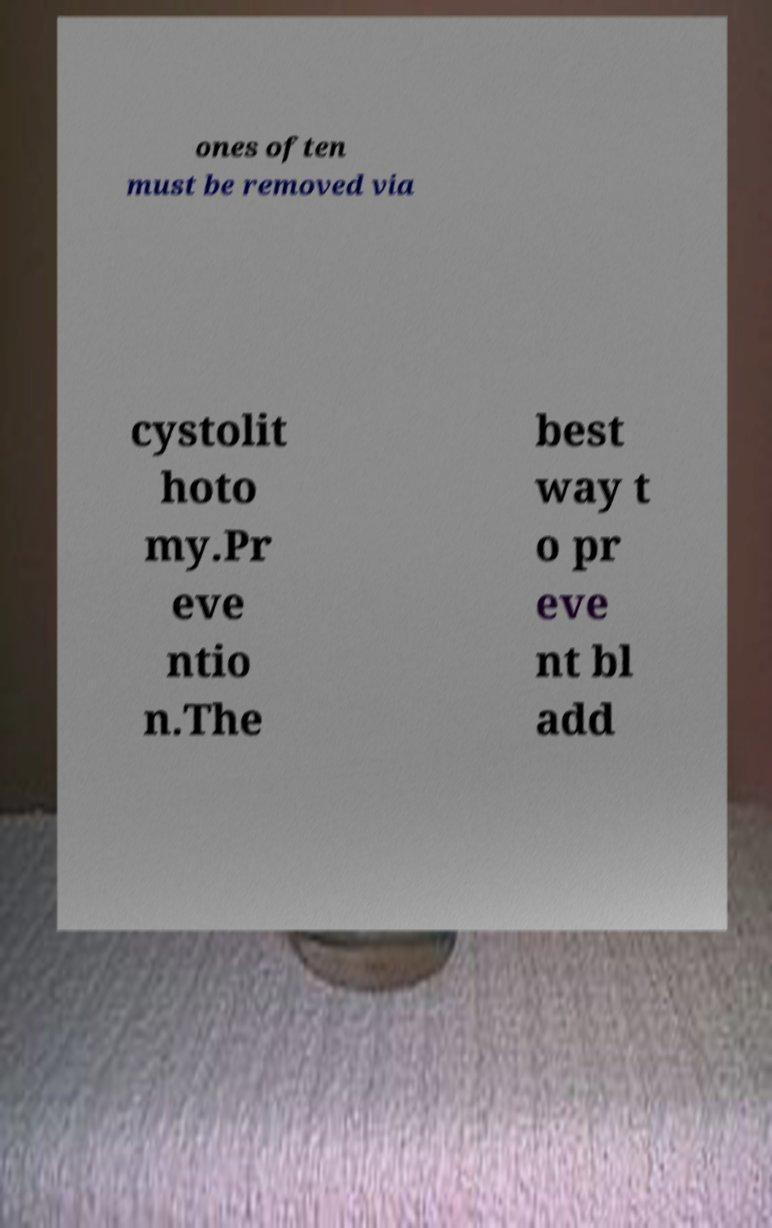Can you accurately transcribe the text from the provided image for me? ones often must be removed via cystolit hoto my.Pr eve ntio n.The best way t o pr eve nt bl add 